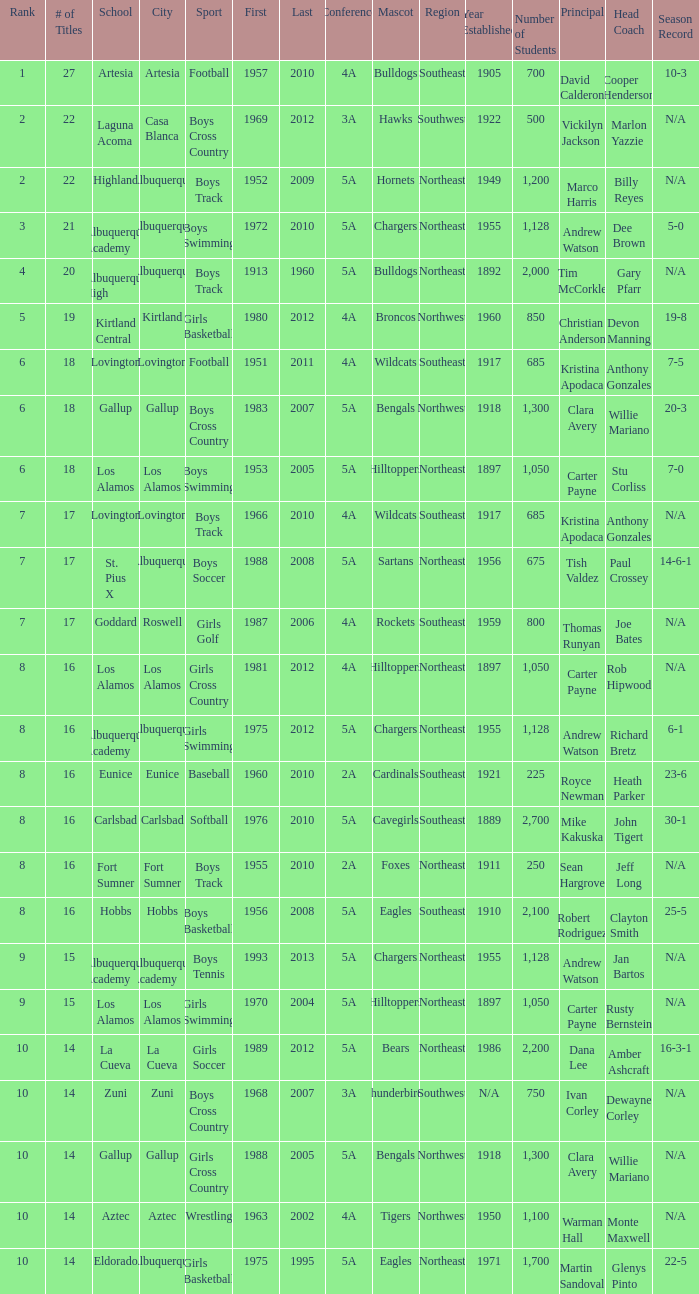What city is the School, Highland, in that ranks less than 8 and had its first title before 1980 and its last title later than 1960? Albuquerque. 